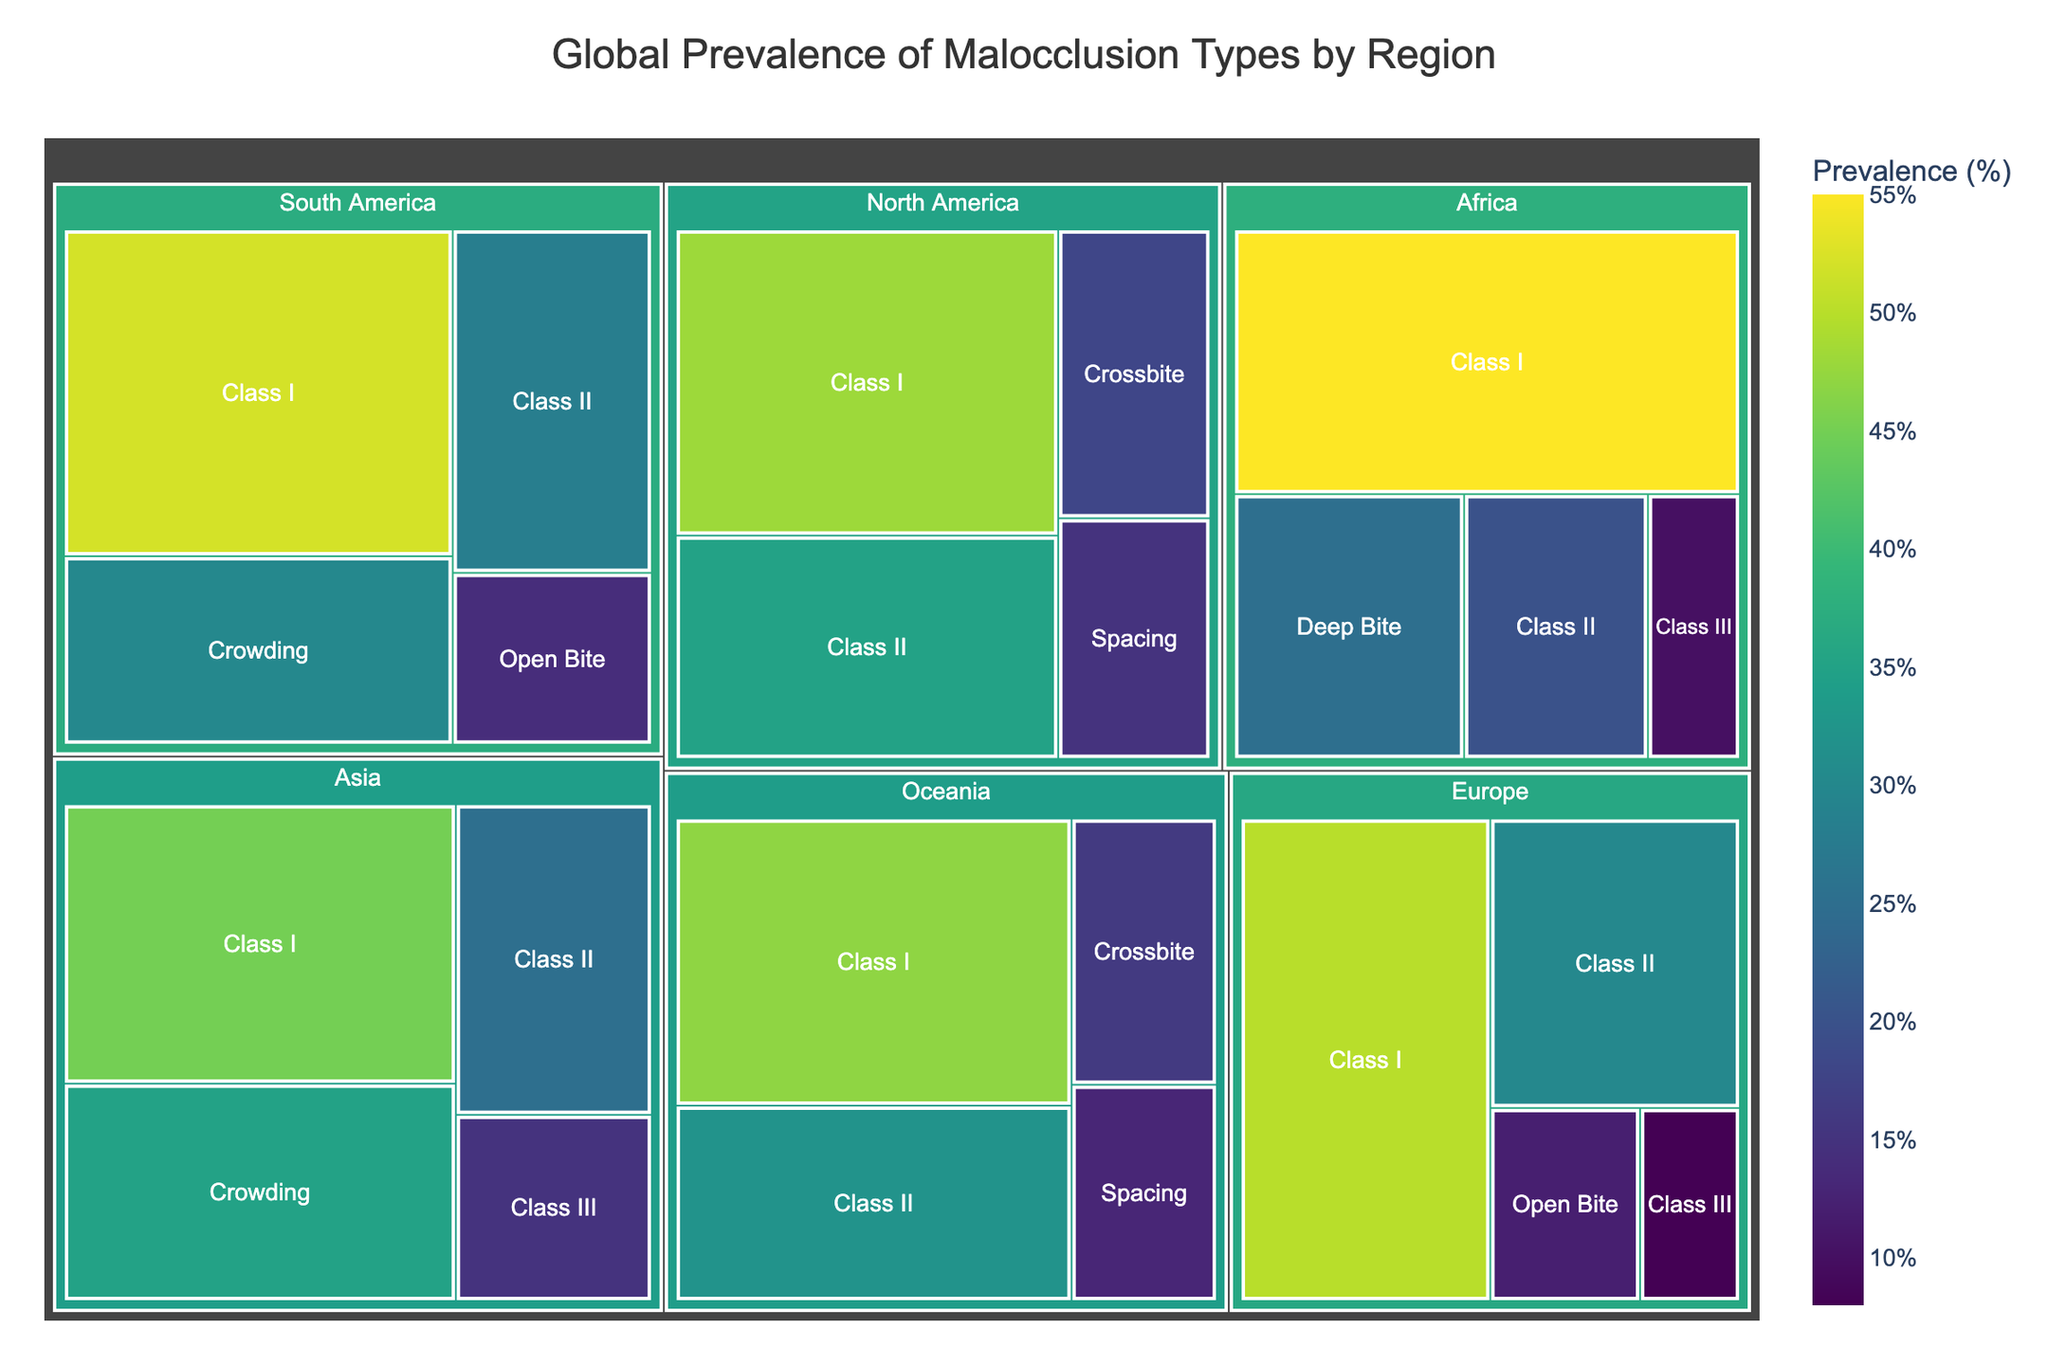What's the title of the figure? The title is typically displayed at the top of the figure and summarizes the subject.
Answer: Global Prevalence of Malocclusion Types by Region Which region has the highest prevalence of Class I malocclusion? In a treemap, larger areas within each region represent higher prevalence. For Class I, identifying the region with the largest area representing it will provide the answer.
Answer: Africa What's the combined prevalence of Class II malocclusion in Asia and Europe? Adding the prevalence percentages for each region: Asia's 25% and Europe's 30%. `25 + 30 = 55`
Answer: 55% Which region shows the least prevalence for Open Bite? By comparing the Open Bite prevalences in each region shown in the treemap, we identify the lowest number. Only Europe and South America have Open Bite with Europe at 12% and South America at 14%. Europe is lower.
Answer: Europe Compare the prevalence of Class III malocclusion in Asia versus Africa. Which region has a higher value? Identify and compare the values for Class III in both regions as shown in the treemap. Asia has 15% and Africa has 10%.
Answer: Asia What is the average prevalence of Class II malocclusion across all regions? Sum the prevalence percentages for Class II across each region and divide by the number of regions. `(25 + 30 + 35 + 20 + 28 + 32) / 6 = 170 / 6 ≈ 28.33`
Answer: 28.33% How does the prevalence of malocclusion types in Oceania compare to North America? Analyze each malocclusion type and their respective prevalences in the two regions. Oceania has Class I (47%), Class II (32%), Crossbite (16%), and Spacing (13%). North America has Class I (48%), Class II (35%), Crossbite (18%), and Spacing (15%). In each corresponding type, North America's values are slightly higher.
Answer: North America What is the prevalence difference between Class I malocclusion in Europe and South America? Subtract the smaller prevalence from the larger. Europe’s Class I is 50% and South America’s is 52%. `52 - 50 = 2`
Answer: 2% Which region exhibits the highest variation in malocclusion types? Variation can be inferred from the range (difference between highest and lowest prevalence). For each region, compare the highest and lowest prevalent malocclusion types. Africa ranges from 55% (Class I) to 10% (Class III), a difference of 45%, which is the highest range observed.
Answer: Africa Is the prevalence of Deep Bite higher in Africa than the prevalence of Crossbite in North America? Compare the values directly. Deep Bite in Africa is 25% versus Crossbite in North America which is 18%.
Answer: Yes 